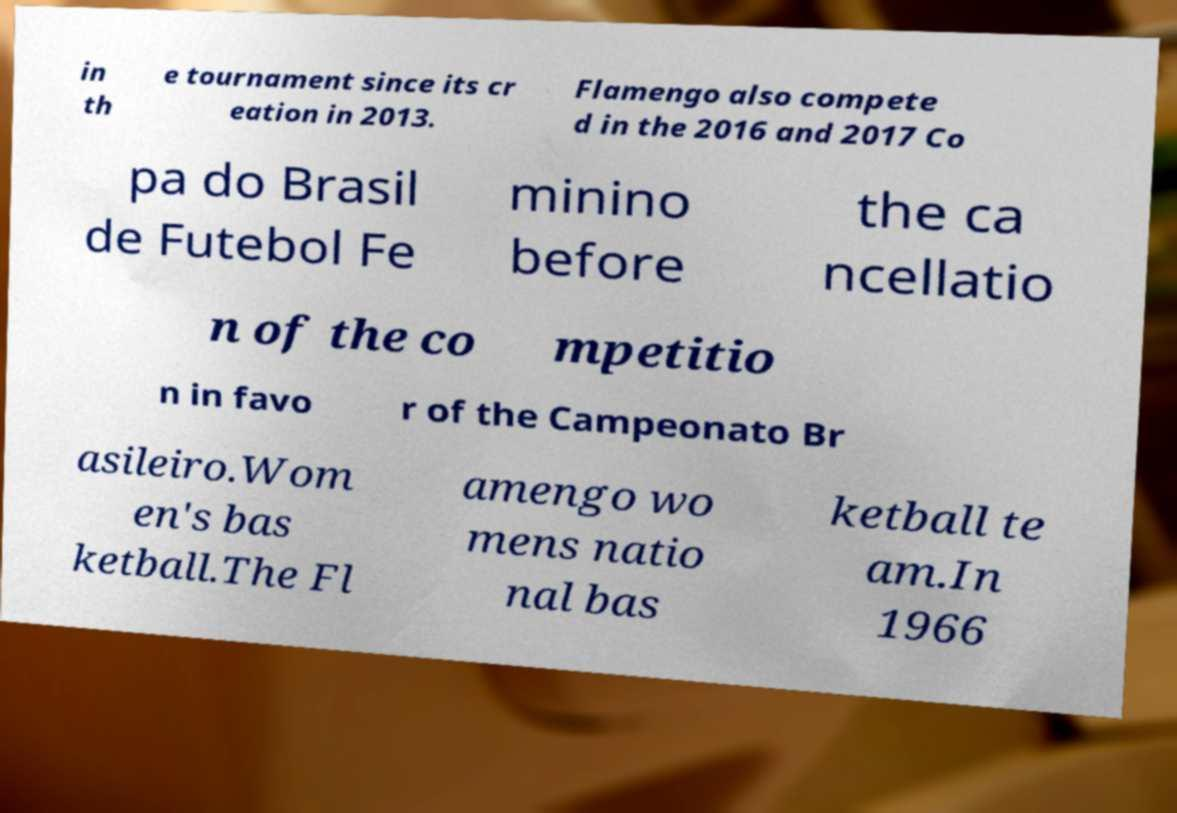I need the written content from this picture converted into text. Can you do that? in th e tournament since its cr eation in 2013. Flamengo also compete d in the 2016 and 2017 Co pa do Brasil de Futebol Fe minino before the ca ncellatio n of the co mpetitio n in favo r of the Campeonato Br asileiro.Wom en's bas ketball.The Fl amengo wo mens natio nal bas ketball te am.In 1966 